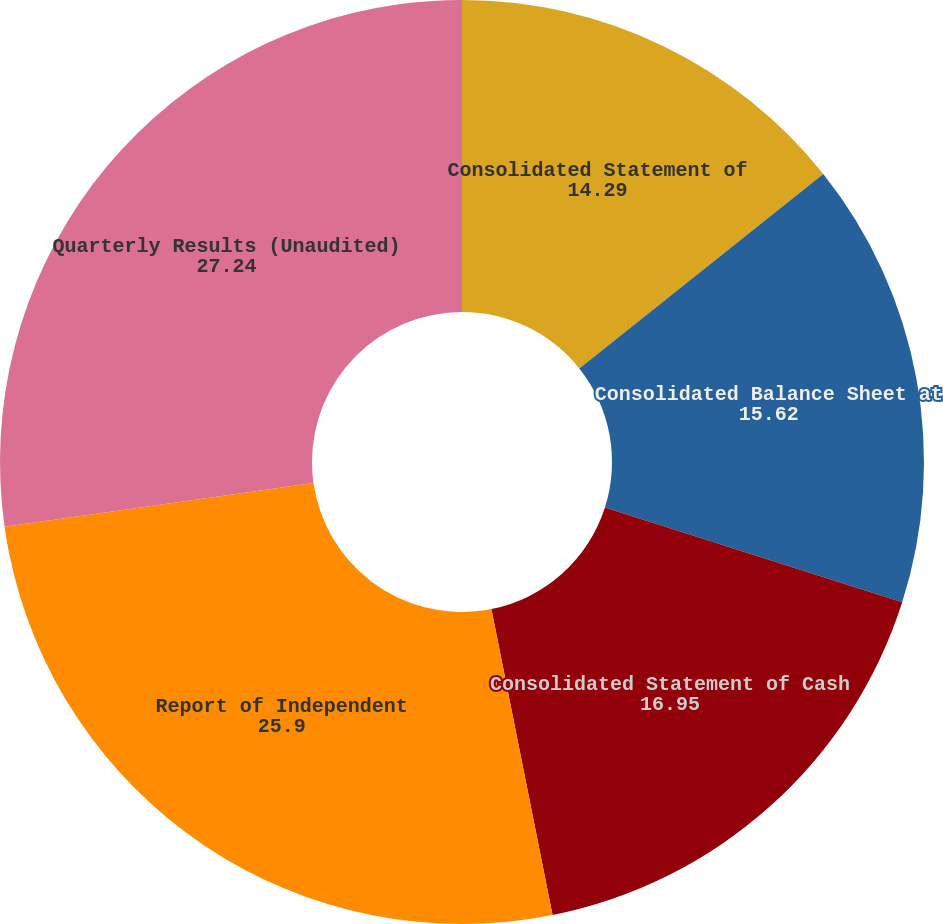Convert chart to OTSL. <chart><loc_0><loc_0><loc_500><loc_500><pie_chart><fcel>Consolidated Statement of<fcel>Consolidated Balance Sheet at<fcel>Consolidated Statement of Cash<fcel>Report of Independent<fcel>Quarterly Results (Unaudited)<nl><fcel>14.29%<fcel>15.62%<fcel>16.95%<fcel>25.9%<fcel>27.24%<nl></chart> 